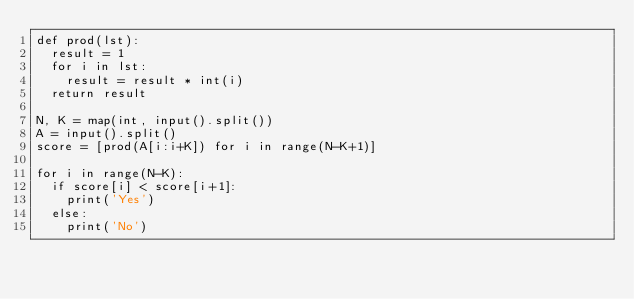<code> <loc_0><loc_0><loc_500><loc_500><_Python_>def prod(lst):
  result = 1
  for i in lst:
    result = result * int(i)
  return result

N, K = map(int, input().split())
A = input().split()
score = [prod(A[i:i+K]) for i in range(N-K+1)]

for i in range(N-K):
  if score[i] < score[i+1]:
    print('Yes')
  else:
    print('No')</code> 